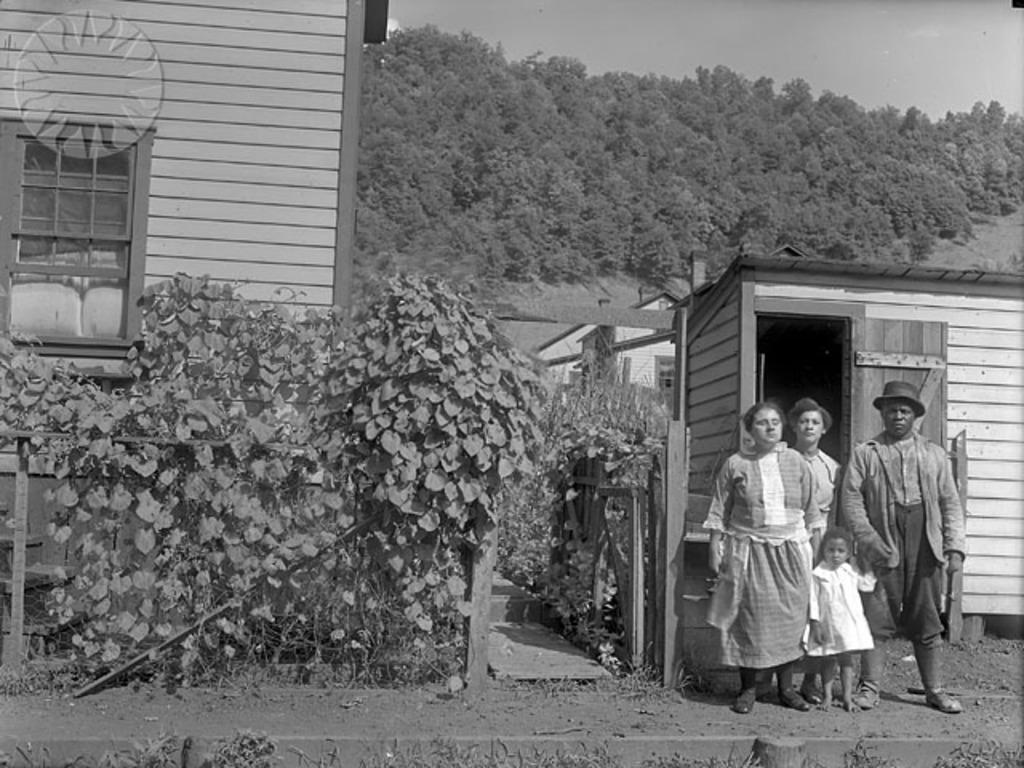In one or two sentences, can you explain what this image depicts? In the picture we can see a black and white photograph of a three people standing together with their child and behind them we can see a small wooden house and beside it we can see some plants and a big wooden house with window and near it also we can see some plants and in the background we can see full of trees and a sky. 